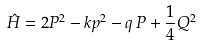<formula> <loc_0><loc_0><loc_500><loc_500>\hat { H } = 2 P ^ { 2 } - k p ^ { 2 } - q \, P + \frac { 1 } { 4 } Q ^ { 2 }</formula> 